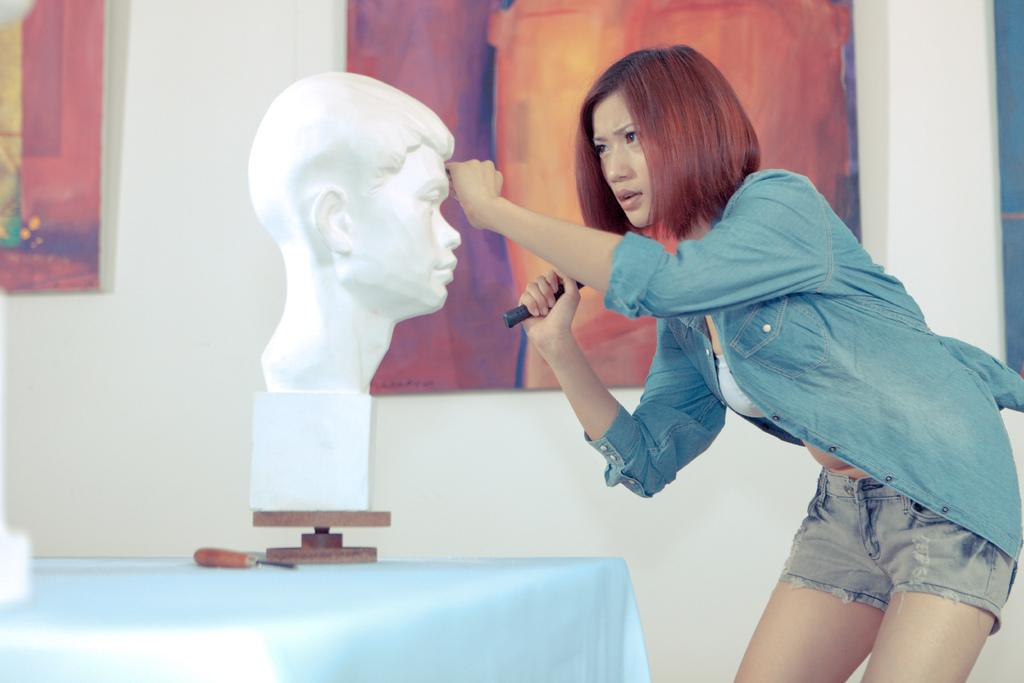Who is the main subject in the image? There is a woman in the image. What is the woman doing in the image? The woman is trying to chisel a statue face. Where is the statue face located in the image? The statue face is present on a table. What other artwork can be seen in the image? There is a painting visible in the image. Where is the painting located in relation to the woman? The painting is behind the woman. What position does the rat take in the image? There is no rat present in the image. What type of picture is the woman holding in the image? The image does not show the woman holding any picture; she is chiseling a statue face. 